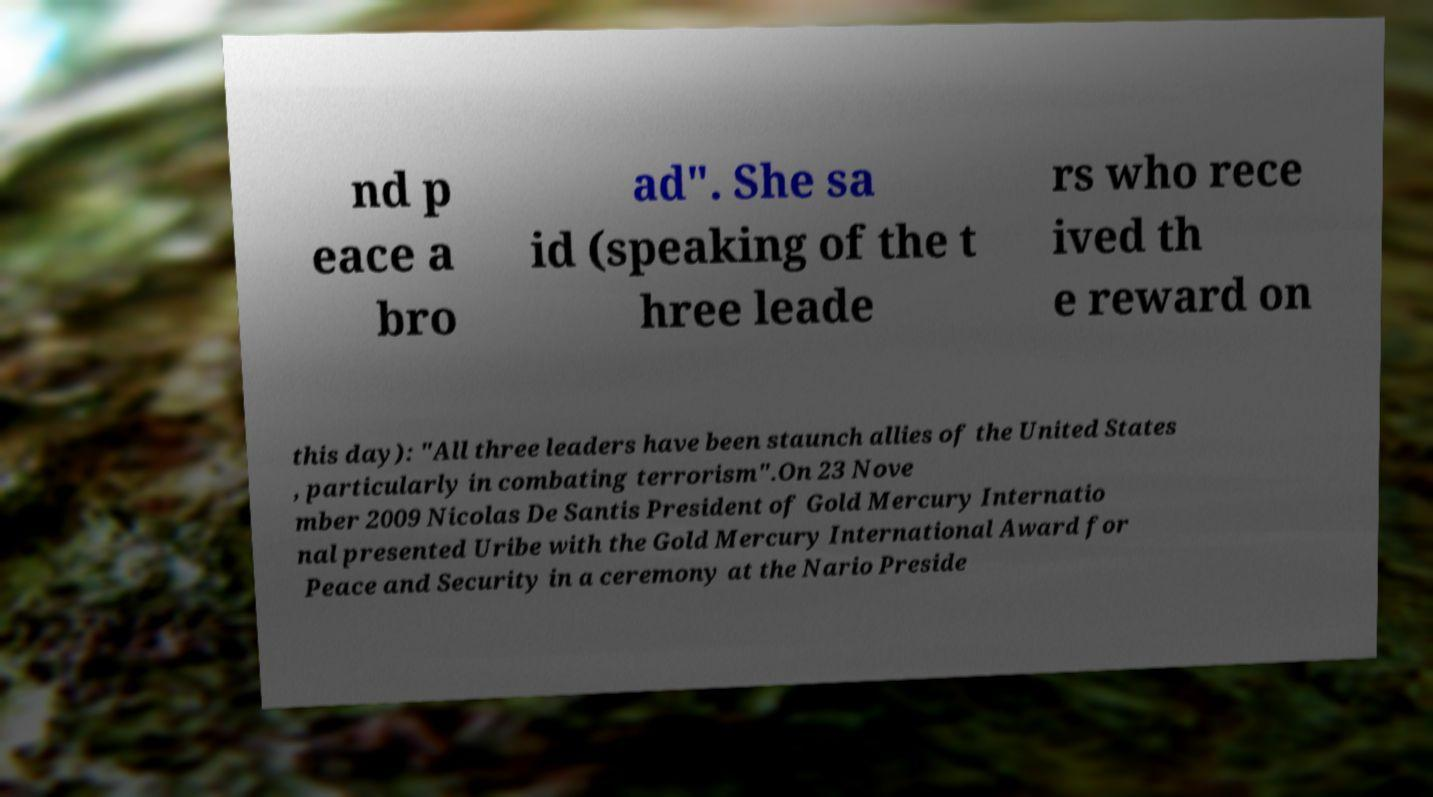Could you extract and type out the text from this image? nd p eace a bro ad". She sa id (speaking of the t hree leade rs who rece ived th e reward on this day): "All three leaders have been staunch allies of the United States , particularly in combating terrorism".On 23 Nove mber 2009 Nicolas De Santis President of Gold Mercury Internatio nal presented Uribe with the Gold Mercury International Award for Peace and Security in a ceremony at the Nario Preside 